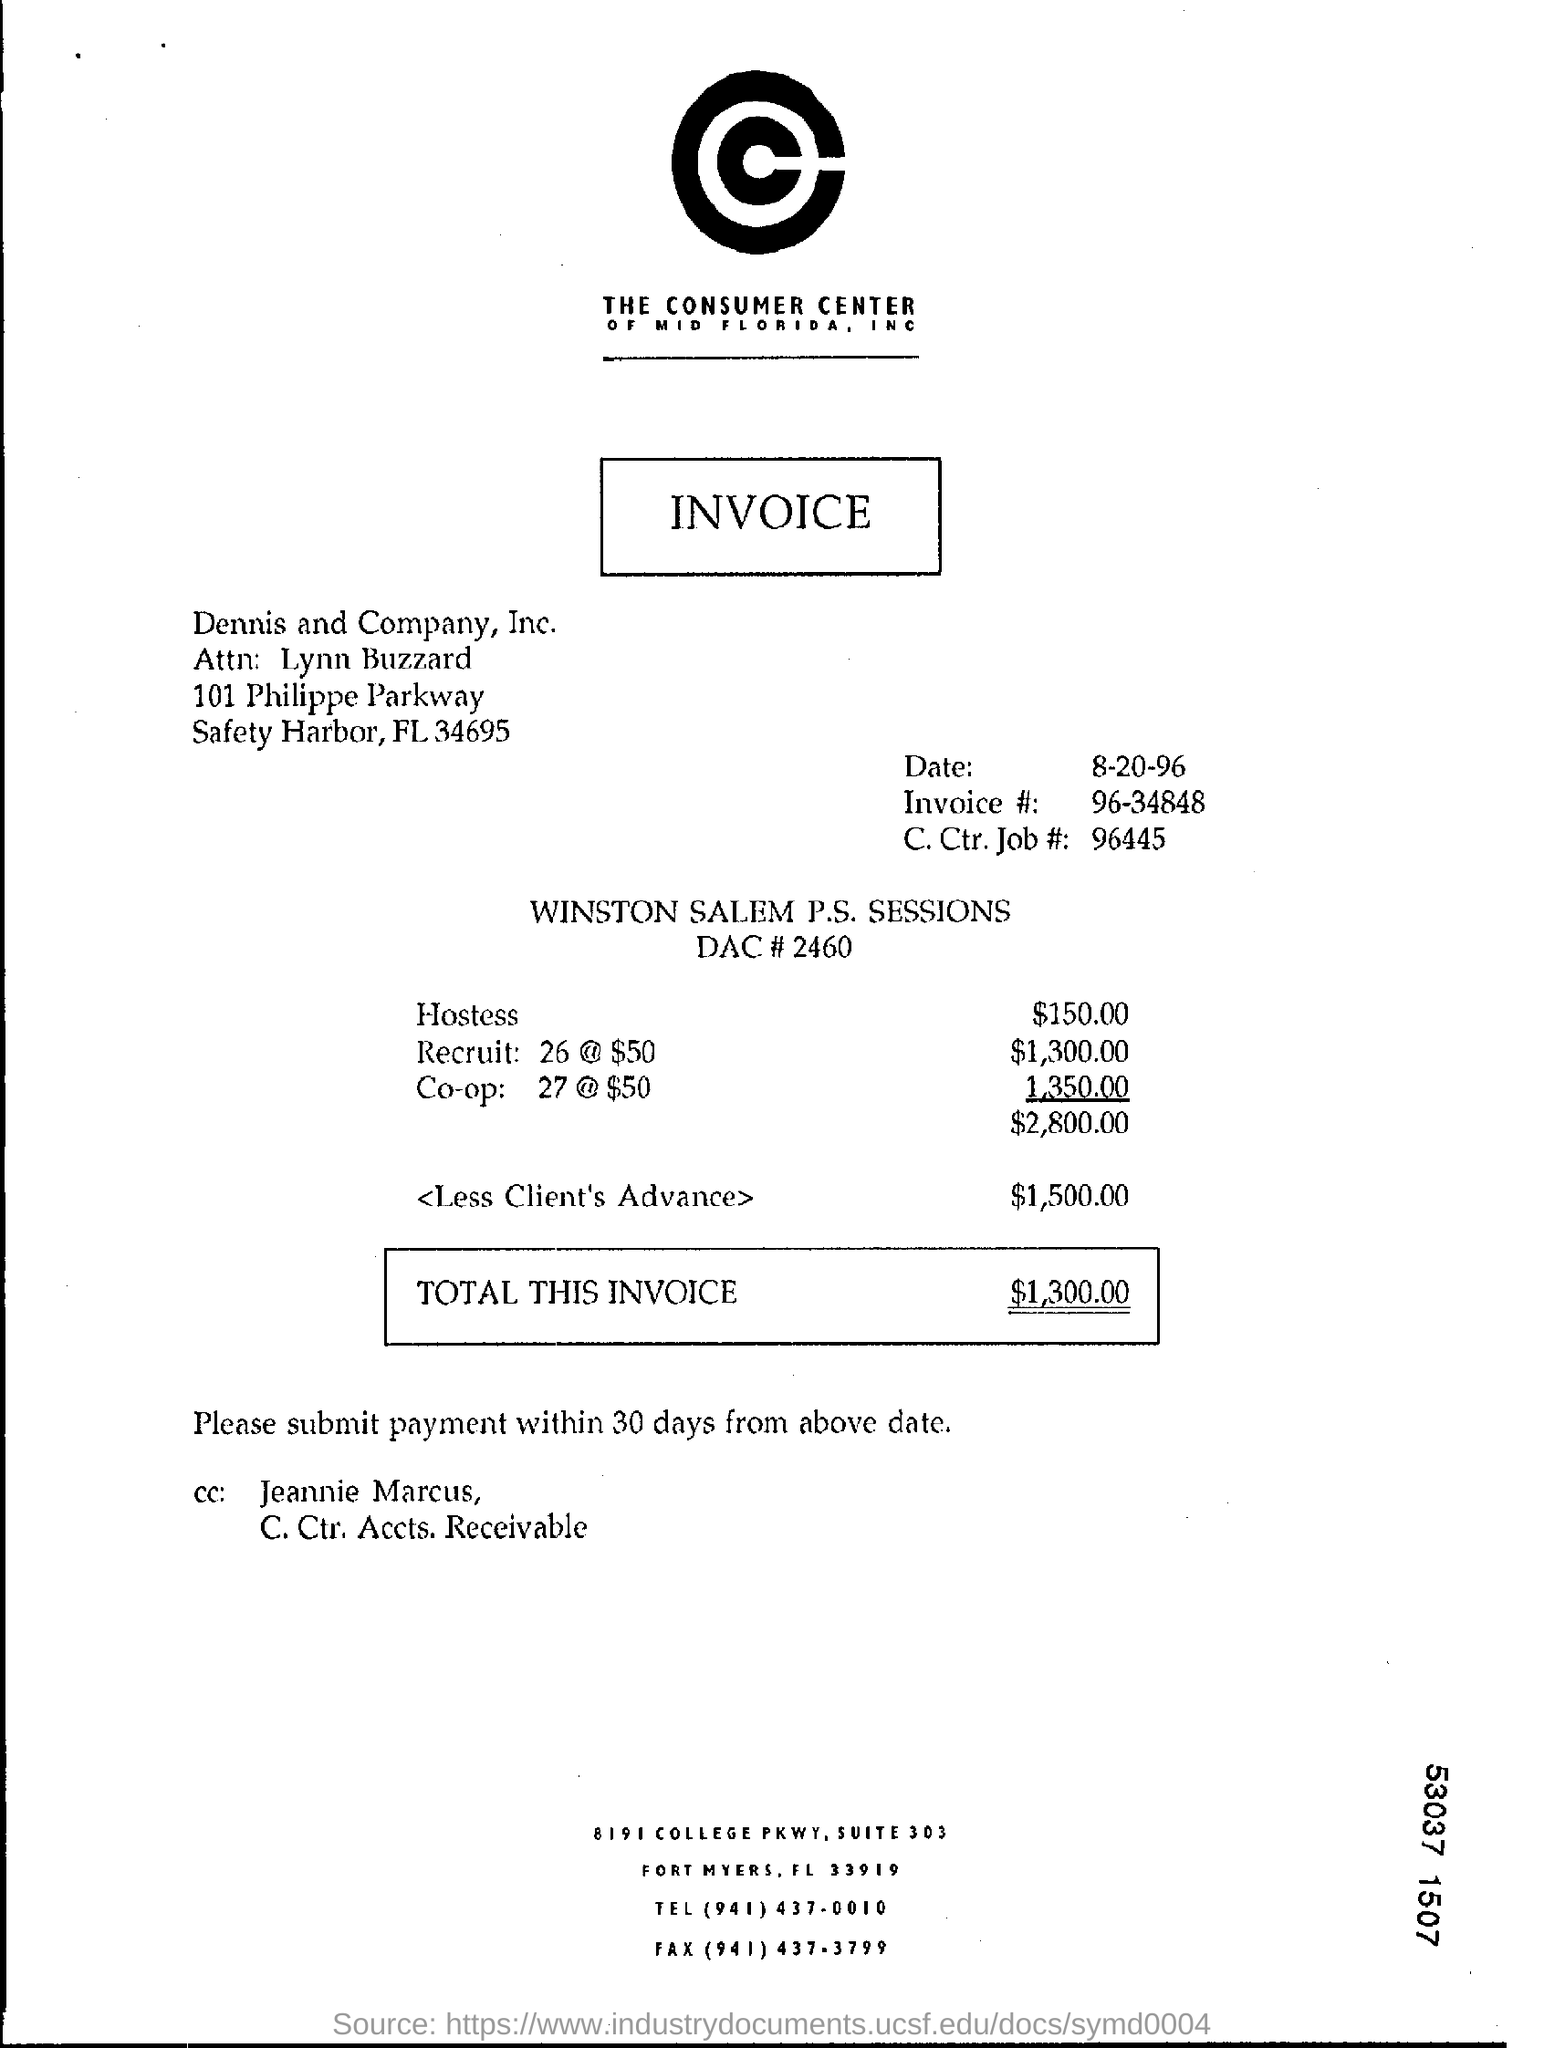What is the zipcode of dennis and company, inc.?
Your response must be concise. 34695. How much is the amount for hostess ?
Give a very brief answer. $150.00. In which state is dennis and company,  inc. at ?
Offer a very short reply. FL. What is the invoice #?
Offer a terse response. 96-34848. When is the invoice dated ?
Your answer should be very brief. 8-20-96. How much is the amount for recruit 26@ $50?
Keep it short and to the point. $1300. Mention the tel number at bottom of the page ?
Give a very brief answer. (941) 437-0010. Whose name is mentioned in the cc?
Provide a short and direct response. Jeannie Marcus. 